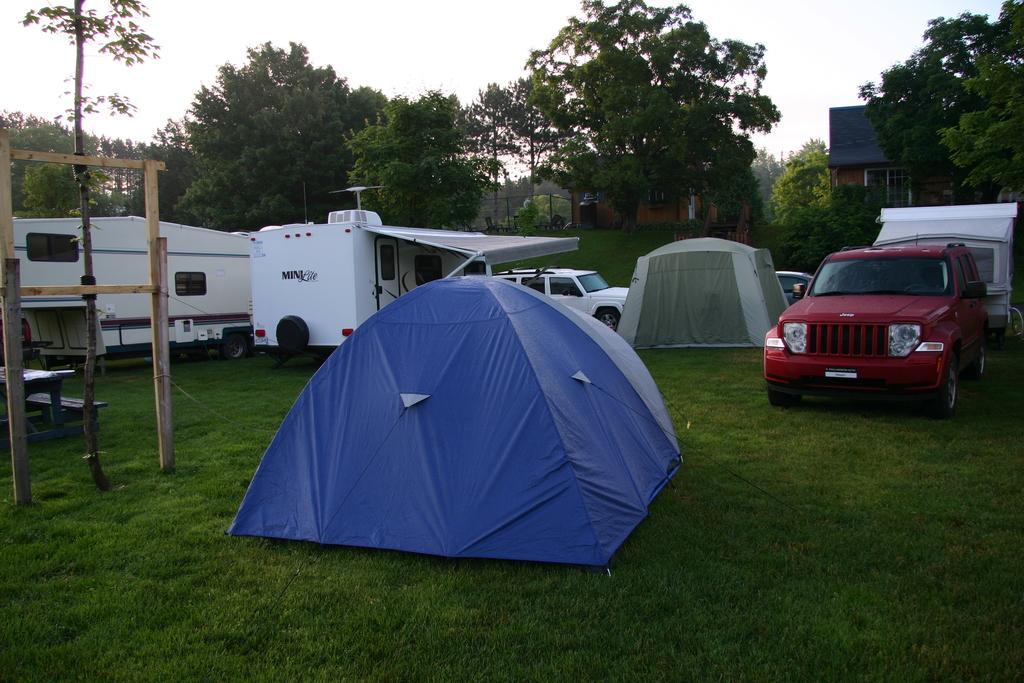Could you give a brief overview of what you see in this image? In this image there are two camps and a few vehicles are parked on the surface of the grass and there is a tree, in front of the tree there is a wooden structure and there is a table. In the background there are trees, buildings and the sky. 